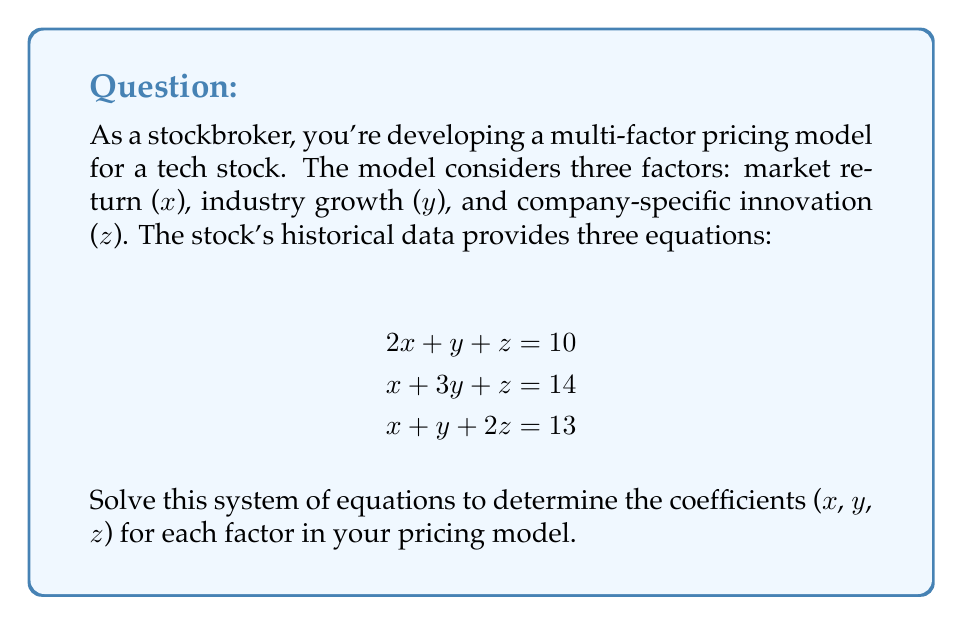Provide a solution to this math problem. Let's solve this system of equations using the Gaussian elimination method:

1) First, write the augmented matrix:

   $$\begin{bmatrix}
   2 & 1 & 1 & | & 10 \\
   1 & 3 & 1 & | & 14 \\
   1 & 1 & 2 & | & 13
   \end{bmatrix}$$

2) Subtract row 1 from row 2 and row 3:

   $$\begin{bmatrix}
   2 & 1 & 1 & | & 10 \\
   -1 & 2 & 0 & | & 4 \\
   -1 & 0 & 1 & | & 3
   \end{bmatrix}$$

3) Add row 2 to row 1:

   $$\begin{bmatrix}
   1 & 3 & 1 & | & 14 \\
   -1 & 2 & 0 & | & 4 \\
   -1 & 0 & 1 & | & 3
   \end{bmatrix}$$

4) Add row 1 to row 2 and row 3:

   $$\begin{bmatrix}
   1 & 3 & 1 & | & 14 \\
   0 & 5 & 1 & | & 18 \\
   0 & 3 & 2 & | & 17
   \end{bmatrix}$$

5) Subtract 3/5 of row 2 from row 3:

   $$\begin{bmatrix}
   1 & 3 & 1 & | & 14 \\
   0 & 5 & 1 & | & 18 \\
   0 & 0 & \frac{7}{5} & | & \frac{37}{5}
   \end{bmatrix}$$

6) Now we can solve by back-substitution:

   From the last row: $z = \frac{37}{5} \div \frac{7}{5} = \frac{37}{7}$

   From the second row: $5y + z = 18$
   $5y + \frac{37}{7} = 18$
   $5y = 18 - \frac{37}{7} = \frac{89}{7}$
   $y = \frac{89}{35}$

   From the first row: $x + 3y + z = 14$
   $x + 3(\frac{89}{35}) + \frac{37}{7} = 14$
   $x = 14 - \frac{267}{35} - \frac{37}{7} = \frac{490}{35} - \frac{267}{35} - \frac{185}{35} = \frac{38}{35}$

Therefore, $x = \frac{38}{35}$, $y = \frac{89}{35}$, and $z = \frac{37}{7}$.
Answer: $x = \frac{38}{35}$, $y = \frac{89}{35}$, $z = \frac{37}{7}$ 